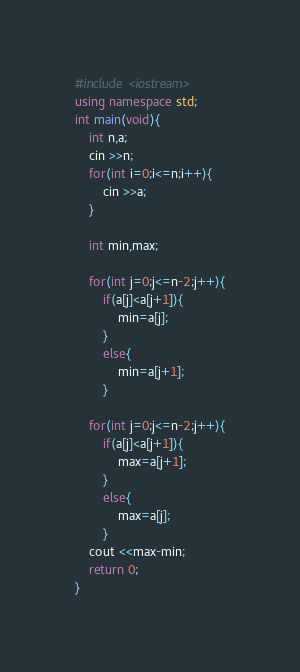<code> <loc_0><loc_0><loc_500><loc_500><_C++_>#include <iostream>
using namespace std;
int main(void){
    int n,a;
    cin >>n;
    for(int i=0;i<=n;i++){
        cin >>a;
    }
    
    int min,max;
    
    for(int j=0;j<=n-2;j++){
        if(a[j]<a[j+1]){
            min=a[j];
        }
        else{
            min=a[j+1];
        }
        
    for(int j=0;j<=n-2;j++){
        if(a[j]<a[j+1]){
            max=a[j+1];
        }
        else{
            max=a[j];
        }
    cout <<max-min;
    return 0;
}</code> 